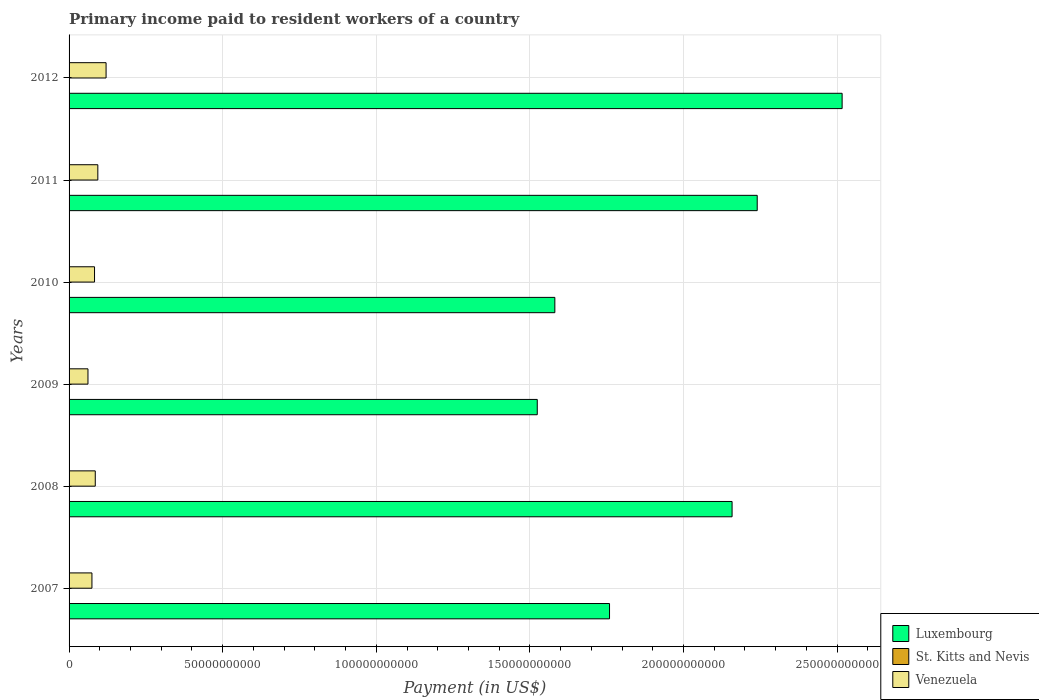Are the number of bars per tick equal to the number of legend labels?
Ensure brevity in your answer.  Yes. Are the number of bars on each tick of the Y-axis equal?
Provide a succinct answer. Yes. What is the label of the 3rd group of bars from the top?
Provide a succinct answer. 2010. In how many cases, is the number of bars for a given year not equal to the number of legend labels?
Ensure brevity in your answer.  0. What is the amount paid to workers in St. Kitts and Nevis in 2010?
Make the answer very short. 3.69e+07. Across all years, what is the maximum amount paid to workers in Luxembourg?
Provide a short and direct response. 2.52e+11. Across all years, what is the minimum amount paid to workers in Luxembourg?
Give a very brief answer. 1.52e+11. In which year was the amount paid to workers in Luxembourg minimum?
Your answer should be very brief. 2009. What is the total amount paid to workers in Venezuela in the graph?
Provide a short and direct response. 5.18e+1. What is the difference between the amount paid to workers in Venezuela in 2007 and that in 2011?
Your answer should be compact. -1.92e+09. What is the difference between the amount paid to workers in Luxembourg in 2010 and the amount paid to workers in St. Kitts and Nevis in 2009?
Ensure brevity in your answer.  1.58e+11. What is the average amount paid to workers in Venezuela per year?
Provide a succinct answer. 8.64e+09. In the year 2012, what is the difference between the amount paid to workers in Luxembourg and amount paid to workers in Venezuela?
Your response must be concise. 2.40e+11. In how many years, is the amount paid to workers in Venezuela greater than 70000000000 US$?
Your answer should be compact. 0. What is the ratio of the amount paid to workers in Venezuela in 2008 to that in 2009?
Give a very brief answer. 1.39. Is the difference between the amount paid to workers in Luxembourg in 2007 and 2010 greater than the difference between the amount paid to workers in Venezuela in 2007 and 2010?
Your response must be concise. Yes. What is the difference between the highest and the second highest amount paid to workers in Venezuela?
Keep it short and to the point. 2.68e+09. What is the difference between the highest and the lowest amount paid to workers in St. Kitts and Nevis?
Provide a succinct answer. 1.66e+07. In how many years, is the amount paid to workers in Luxembourg greater than the average amount paid to workers in Luxembourg taken over all years?
Make the answer very short. 3. What does the 3rd bar from the top in 2011 represents?
Keep it short and to the point. Luxembourg. What does the 2nd bar from the bottom in 2010 represents?
Make the answer very short. St. Kitts and Nevis. Is it the case that in every year, the sum of the amount paid to workers in St. Kitts and Nevis and amount paid to workers in Venezuela is greater than the amount paid to workers in Luxembourg?
Offer a terse response. No. Are the values on the major ticks of X-axis written in scientific E-notation?
Provide a succinct answer. No. Where does the legend appear in the graph?
Give a very brief answer. Bottom right. How are the legend labels stacked?
Offer a terse response. Vertical. What is the title of the graph?
Offer a terse response. Primary income paid to resident workers of a country. What is the label or title of the X-axis?
Ensure brevity in your answer.  Payment (in US$). What is the label or title of the Y-axis?
Your answer should be very brief. Years. What is the Payment (in US$) in Luxembourg in 2007?
Offer a terse response. 1.76e+11. What is the Payment (in US$) of St. Kitts and Nevis in 2007?
Offer a terse response. 4.57e+07. What is the Payment (in US$) of Venezuela in 2007?
Provide a short and direct response. 7.44e+09. What is the Payment (in US$) of Luxembourg in 2008?
Give a very brief answer. 2.16e+11. What is the Payment (in US$) of St. Kitts and Nevis in 2008?
Provide a short and direct response. 4.42e+07. What is the Payment (in US$) in Venezuela in 2008?
Provide a short and direct response. 8.53e+09. What is the Payment (in US$) in Luxembourg in 2009?
Make the answer very short. 1.52e+11. What is the Payment (in US$) of St. Kitts and Nevis in 2009?
Provide a short and direct response. 4.44e+07. What is the Payment (in US$) in Venezuela in 2009?
Keep it short and to the point. 6.15e+09. What is the Payment (in US$) of Luxembourg in 2010?
Your answer should be very brief. 1.58e+11. What is the Payment (in US$) in St. Kitts and Nevis in 2010?
Provide a short and direct response. 3.69e+07. What is the Payment (in US$) of Venezuela in 2010?
Your response must be concise. 8.28e+09. What is the Payment (in US$) in Luxembourg in 2011?
Keep it short and to the point. 2.24e+11. What is the Payment (in US$) in St. Kitts and Nevis in 2011?
Offer a terse response. 3.60e+07. What is the Payment (in US$) in Venezuela in 2011?
Offer a very short reply. 9.36e+09. What is the Payment (in US$) of Luxembourg in 2012?
Offer a terse response. 2.52e+11. What is the Payment (in US$) in St. Kitts and Nevis in 2012?
Make the answer very short. 2.91e+07. What is the Payment (in US$) in Venezuela in 2012?
Offer a very short reply. 1.20e+1. Across all years, what is the maximum Payment (in US$) in Luxembourg?
Your answer should be compact. 2.52e+11. Across all years, what is the maximum Payment (in US$) of St. Kitts and Nevis?
Ensure brevity in your answer.  4.57e+07. Across all years, what is the maximum Payment (in US$) in Venezuela?
Your response must be concise. 1.20e+1. Across all years, what is the minimum Payment (in US$) in Luxembourg?
Keep it short and to the point. 1.52e+11. Across all years, what is the minimum Payment (in US$) in St. Kitts and Nevis?
Make the answer very short. 2.91e+07. Across all years, what is the minimum Payment (in US$) in Venezuela?
Provide a short and direct response. 6.15e+09. What is the total Payment (in US$) of Luxembourg in the graph?
Offer a terse response. 1.18e+12. What is the total Payment (in US$) of St. Kitts and Nevis in the graph?
Offer a terse response. 2.36e+08. What is the total Payment (in US$) of Venezuela in the graph?
Give a very brief answer. 5.18e+1. What is the difference between the Payment (in US$) of Luxembourg in 2007 and that in 2008?
Offer a terse response. -3.99e+1. What is the difference between the Payment (in US$) in St. Kitts and Nevis in 2007 and that in 2008?
Give a very brief answer. 1.53e+06. What is the difference between the Payment (in US$) of Venezuela in 2007 and that in 2008?
Your response must be concise. -1.09e+09. What is the difference between the Payment (in US$) of Luxembourg in 2007 and that in 2009?
Make the answer very short. 2.35e+1. What is the difference between the Payment (in US$) of St. Kitts and Nevis in 2007 and that in 2009?
Your answer should be compact. 1.29e+06. What is the difference between the Payment (in US$) of Venezuela in 2007 and that in 2009?
Give a very brief answer. 1.29e+09. What is the difference between the Payment (in US$) of Luxembourg in 2007 and that in 2010?
Keep it short and to the point. 1.78e+1. What is the difference between the Payment (in US$) in St. Kitts and Nevis in 2007 and that in 2010?
Make the answer very short. 8.79e+06. What is the difference between the Payment (in US$) of Venezuela in 2007 and that in 2010?
Offer a terse response. -8.44e+08. What is the difference between the Payment (in US$) in Luxembourg in 2007 and that in 2011?
Provide a short and direct response. -4.81e+1. What is the difference between the Payment (in US$) of St. Kitts and Nevis in 2007 and that in 2011?
Make the answer very short. 9.65e+06. What is the difference between the Payment (in US$) in Venezuela in 2007 and that in 2011?
Offer a very short reply. -1.92e+09. What is the difference between the Payment (in US$) of Luxembourg in 2007 and that in 2012?
Provide a short and direct response. -7.57e+1. What is the difference between the Payment (in US$) of St. Kitts and Nevis in 2007 and that in 2012?
Ensure brevity in your answer.  1.66e+07. What is the difference between the Payment (in US$) in Venezuela in 2007 and that in 2012?
Your answer should be very brief. -4.60e+09. What is the difference between the Payment (in US$) in Luxembourg in 2008 and that in 2009?
Offer a terse response. 6.34e+1. What is the difference between the Payment (in US$) of St. Kitts and Nevis in 2008 and that in 2009?
Give a very brief answer. -2.35e+05. What is the difference between the Payment (in US$) in Venezuela in 2008 and that in 2009?
Ensure brevity in your answer.  2.38e+09. What is the difference between the Payment (in US$) in Luxembourg in 2008 and that in 2010?
Your response must be concise. 5.77e+1. What is the difference between the Payment (in US$) in St. Kitts and Nevis in 2008 and that in 2010?
Keep it short and to the point. 7.26e+06. What is the difference between the Payment (in US$) in Venezuela in 2008 and that in 2010?
Give a very brief answer. 2.42e+08. What is the difference between the Payment (in US$) in Luxembourg in 2008 and that in 2011?
Your answer should be very brief. -8.18e+09. What is the difference between the Payment (in US$) in St. Kitts and Nevis in 2008 and that in 2011?
Your answer should be compact. 8.13e+06. What is the difference between the Payment (in US$) of Venezuela in 2008 and that in 2011?
Your response must be concise. -8.35e+08. What is the difference between the Payment (in US$) of Luxembourg in 2008 and that in 2012?
Your response must be concise. -3.58e+1. What is the difference between the Payment (in US$) in St. Kitts and Nevis in 2008 and that in 2012?
Keep it short and to the point. 1.51e+07. What is the difference between the Payment (in US$) in Venezuela in 2008 and that in 2012?
Make the answer very short. -3.52e+09. What is the difference between the Payment (in US$) of Luxembourg in 2009 and that in 2010?
Your answer should be very brief. -5.72e+09. What is the difference between the Payment (in US$) of St. Kitts and Nevis in 2009 and that in 2010?
Ensure brevity in your answer.  7.50e+06. What is the difference between the Payment (in US$) of Venezuela in 2009 and that in 2010?
Provide a short and direct response. -2.14e+09. What is the difference between the Payment (in US$) of Luxembourg in 2009 and that in 2011?
Your answer should be compact. -7.16e+1. What is the difference between the Payment (in US$) of St. Kitts and Nevis in 2009 and that in 2011?
Provide a succinct answer. 8.36e+06. What is the difference between the Payment (in US$) in Venezuela in 2009 and that in 2011?
Ensure brevity in your answer.  -3.21e+09. What is the difference between the Payment (in US$) of Luxembourg in 2009 and that in 2012?
Provide a succinct answer. -9.92e+1. What is the difference between the Payment (in US$) in St. Kitts and Nevis in 2009 and that in 2012?
Ensure brevity in your answer.  1.53e+07. What is the difference between the Payment (in US$) in Venezuela in 2009 and that in 2012?
Your answer should be very brief. -5.90e+09. What is the difference between the Payment (in US$) of Luxembourg in 2010 and that in 2011?
Keep it short and to the point. -6.59e+1. What is the difference between the Payment (in US$) of St. Kitts and Nevis in 2010 and that in 2011?
Keep it short and to the point. 8.65e+05. What is the difference between the Payment (in US$) in Venezuela in 2010 and that in 2011?
Keep it short and to the point. -1.08e+09. What is the difference between the Payment (in US$) of Luxembourg in 2010 and that in 2012?
Your answer should be very brief. -9.35e+1. What is the difference between the Payment (in US$) of St. Kitts and Nevis in 2010 and that in 2012?
Your answer should be compact. 7.81e+06. What is the difference between the Payment (in US$) of Venezuela in 2010 and that in 2012?
Keep it short and to the point. -3.76e+09. What is the difference between the Payment (in US$) of Luxembourg in 2011 and that in 2012?
Provide a succinct answer. -2.76e+1. What is the difference between the Payment (in US$) of St. Kitts and Nevis in 2011 and that in 2012?
Provide a short and direct response. 6.94e+06. What is the difference between the Payment (in US$) of Venezuela in 2011 and that in 2012?
Keep it short and to the point. -2.68e+09. What is the difference between the Payment (in US$) of Luxembourg in 2007 and the Payment (in US$) of St. Kitts and Nevis in 2008?
Provide a short and direct response. 1.76e+11. What is the difference between the Payment (in US$) in Luxembourg in 2007 and the Payment (in US$) in Venezuela in 2008?
Your response must be concise. 1.67e+11. What is the difference between the Payment (in US$) of St. Kitts and Nevis in 2007 and the Payment (in US$) of Venezuela in 2008?
Provide a short and direct response. -8.48e+09. What is the difference between the Payment (in US$) of Luxembourg in 2007 and the Payment (in US$) of St. Kitts and Nevis in 2009?
Make the answer very short. 1.76e+11. What is the difference between the Payment (in US$) in Luxembourg in 2007 and the Payment (in US$) in Venezuela in 2009?
Provide a succinct answer. 1.70e+11. What is the difference between the Payment (in US$) in St. Kitts and Nevis in 2007 and the Payment (in US$) in Venezuela in 2009?
Your response must be concise. -6.10e+09. What is the difference between the Payment (in US$) in Luxembourg in 2007 and the Payment (in US$) in St. Kitts and Nevis in 2010?
Offer a very short reply. 1.76e+11. What is the difference between the Payment (in US$) of Luxembourg in 2007 and the Payment (in US$) of Venezuela in 2010?
Keep it short and to the point. 1.68e+11. What is the difference between the Payment (in US$) of St. Kitts and Nevis in 2007 and the Payment (in US$) of Venezuela in 2010?
Provide a succinct answer. -8.24e+09. What is the difference between the Payment (in US$) of Luxembourg in 2007 and the Payment (in US$) of St. Kitts and Nevis in 2011?
Provide a short and direct response. 1.76e+11. What is the difference between the Payment (in US$) in Luxembourg in 2007 and the Payment (in US$) in Venezuela in 2011?
Provide a succinct answer. 1.67e+11. What is the difference between the Payment (in US$) in St. Kitts and Nevis in 2007 and the Payment (in US$) in Venezuela in 2011?
Give a very brief answer. -9.32e+09. What is the difference between the Payment (in US$) of Luxembourg in 2007 and the Payment (in US$) of St. Kitts and Nevis in 2012?
Make the answer very short. 1.76e+11. What is the difference between the Payment (in US$) in Luxembourg in 2007 and the Payment (in US$) in Venezuela in 2012?
Provide a short and direct response. 1.64e+11. What is the difference between the Payment (in US$) in St. Kitts and Nevis in 2007 and the Payment (in US$) in Venezuela in 2012?
Your answer should be very brief. -1.20e+1. What is the difference between the Payment (in US$) of Luxembourg in 2008 and the Payment (in US$) of St. Kitts and Nevis in 2009?
Ensure brevity in your answer.  2.16e+11. What is the difference between the Payment (in US$) of Luxembourg in 2008 and the Payment (in US$) of Venezuela in 2009?
Offer a very short reply. 2.10e+11. What is the difference between the Payment (in US$) of St. Kitts and Nevis in 2008 and the Payment (in US$) of Venezuela in 2009?
Make the answer very short. -6.10e+09. What is the difference between the Payment (in US$) of Luxembourg in 2008 and the Payment (in US$) of St. Kitts and Nevis in 2010?
Your answer should be compact. 2.16e+11. What is the difference between the Payment (in US$) of Luxembourg in 2008 and the Payment (in US$) of Venezuela in 2010?
Make the answer very short. 2.08e+11. What is the difference between the Payment (in US$) of St. Kitts and Nevis in 2008 and the Payment (in US$) of Venezuela in 2010?
Your answer should be compact. -8.24e+09. What is the difference between the Payment (in US$) in Luxembourg in 2008 and the Payment (in US$) in St. Kitts and Nevis in 2011?
Your answer should be compact. 2.16e+11. What is the difference between the Payment (in US$) of Luxembourg in 2008 and the Payment (in US$) of Venezuela in 2011?
Your response must be concise. 2.06e+11. What is the difference between the Payment (in US$) in St. Kitts and Nevis in 2008 and the Payment (in US$) in Venezuela in 2011?
Keep it short and to the point. -9.32e+09. What is the difference between the Payment (in US$) of Luxembourg in 2008 and the Payment (in US$) of St. Kitts and Nevis in 2012?
Provide a short and direct response. 2.16e+11. What is the difference between the Payment (in US$) of Luxembourg in 2008 and the Payment (in US$) of Venezuela in 2012?
Give a very brief answer. 2.04e+11. What is the difference between the Payment (in US$) in St. Kitts and Nevis in 2008 and the Payment (in US$) in Venezuela in 2012?
Make the answer very short. -1.20e+1. What is the difference between the Payment (in US$) in Luxembourg in 2009 and the Payment (in US$) in St. Kitts and Nevis in 2010?
Your answer should be very brief. 1.52e+11. What is the difference between the Payment (in US$) in Luxembourg in 2009 and the Payment (in US$) in Venezuela in 2010?
Provide a succinct answer. 1.44e+11. What is the difference between the Payment (in US$) of St. Kitts and Nevis in 2009 and the Payment (in US$) of Venezuela in 2010?
Offer a terse response. -8.24e+09. What is the difference between the Payment (in US$) in Luxembourg in 2009 and the Payment (in US$) in St. Kitts and Nevis in 2011?
Provide a succinct answer. 1.52e+11. What is the difference between the Payment (in US$) in Luxembourg in 2009 and the Payment (in US$) in Venezuela in 2011?
Your answer should be compact. 1.43e+11. What is the difference between the Payment (in US$) in St. Kitts and Nevis in 2009 and the Payment (in US$) in Venezuela in 2011?
Provide a short and direct response. -9.32e+09. What is the difference between the Payment (in US$) in Luxembourg in 2009 and the Payment (in US$) in St. Kitts and Nevis in 2012?
Provide a short and direct response. 1.52e+11. What is the difference between the Payment (in US$) in Luxembourg in 2009 and the Payment (in US$) in Venezuela in 2012?
Provide a succinct answer. 1.40e+11. What is the difference between the Payment (in US$) of St. Kitts and Nevis in 2009 and the Payment (in US$) of Venezuela in 2012?
Keep it short and to the point. -1.20e+1. What is the difference between the Payment (in US$) of Luxembourg in 2010 and the Payment (in US$) of St. Kitts and Nevis in 2011?
Your response must be concise. 1.58e+11. What is the difference between the Payment (in US$) of Luxembourg in 2010 and the Payment (in US$) of Venezuela in 2011?
Offer a very short reply. 1.49e+11. What is the difference between the Payment (in US$) in St. Kitts and Nevis in 2010 and the Payment (in US$) in Venezuela in 2011?
Offer a terse response. -9.33e+09. What is the difference between the Payment (in US$) in Luxembourg in 2010 and the Payment (in US$) in St. Kitts and Nevis in 2012?
Keep it short and to the point. 1.58e+11. What is the difference between the Payment (in US$) of Luxembourg in 2010 and the Payment (in US$) of Venezuela in 2012?
Your response must be concise. 1.46e+11. What is the difference between the Payment (in US$) of St. Kitts and Nevis in 2010 and the Payment (in US$) of Venezuela in 2012?
Offer a terse response. -1.20e+1. What is the difference between the Payment (in US$) of Luxembourg in 2011 and the Payment (in US$) of St. Kitts and Nevis in 2012?
Your answer should be very brief. 2.24e+11. What is the difference between the Payment (in US$) in Luxembourg in 2011 and the Payment (in US$) in Venezuela in 2012?
Give a very brief answer. 2.12e+11. What is the difference between the Payment (in US$) in St. Kitts and Nevis in 2011 and the Payment (in US$) in Venezuela in 2012?
Offer a terse response. -1.20e+1. What is the average Payment (in US$) in Luxembourg per year?
Give a very brief answer. 1.96e+11. What is the average Payment (in US$) of St. Kitts and Nevis per year?
Make the answer very short. 3.94e+07. What is the average Payment (in US$) in Venezuela per year?
Offer a very short reply. 8.64e+09. In the year 2007, what is the difference between the Payment (in US$) in Luxembourg and Payment (in US$) in St. Kitts and Nevis?
Give a very brief answer. 1.76e+11. In the year 2007, what is the difference between the Payment (in US$) of Luxembourg and Payment (in US$) of Venezuela?
Make the answer very short. 1.68e+11. In the year 2007, what is the difference between the Payment (in US$) of St. Kitts and Nevis and Payment (in US$) of Venezuela?
Make the answer very short. -7.40e+09. In the year 2008, what is the difference between the Payment (in US$) in Luxembourg and Payment (in US$) in St. Kitts and Nevis?
Keep it short and to the point. 2.16e+11. In the year 2008, what is the difference between the Payment (in US$) in Luxembourg and Payment (in US$) in Venezuela?
Ensure brevity in your answer.  2.07e+11. In the year 2008, what is the difference between the Payment (in US$) in St. Kitts and Nevis and Payment (in US$) in Venezuela?
Your answer should be very brief. -8.48e+09. In the year 2009, what is the difference between the Payment (in US$) of Luxembourg and Payment (in US$) of St. Kitts and Nevis?
Keep it short and to the point. 1.52e+11. In the year 2009, what is the difference between the Payment (in US$) of Luxembourg and Payment (in US$) of Venezuela?
Offer a terse response. 1.46e+11. In the year 2009, what is the difference between the Payment (in US$) in St. Kitts and Nevis and Payment (in US$) in Venezuela?
Provide a short and direct response. -6.10e+09. In the year 2010, what is the difference between the Payment (in US$) in Luxembourg and Payment (in US$) in St. Kitts and Nevis?
Your answer should be compact. 1.58e+11. In the year 2010, what is the difference between the Payment (in US$) in Luxembourg and Payment (in US$) in Venezuela?
Your answer should be very brief. 1.50e+11. In the year 2010, what is the difference between the Payment (in US$) of St. Kitts and Nevis and Payment (in US$) of Venezuela?
Make the answer very short. -8.25e+09. In the year 2011, what is the difference between the Payment (in US$) in Luxembourg and Payment (in US$) in St. Kitts and Nevis?
Ensure brevity in your answer.  2.24e+11. In the year 2011, what is the difference between the Payment (in US$) of Luxembourg and Payment (in US$) of Venezuela?
Your answer should be very brief. 2.15e+11. In the year 2011, what is the difference between the Payment (in US$) in St. Kitts and Nevis and Payment (in US$) in Venezuela?
Keep it short and to the point. -9.33e+09. In the year 2012, what is the difference between the Payment (in US$) in Luxembourg and Payment (in US$) in St. Kitts and Nevis?
Provide a succinct answer. 2.52e+11. In the year 2012, what is the difference between the Payment (in US$) in Luxembourg and Payment (in US$) in Venezuela?
Provide a short and direct response. 2.40e+11. In the year 2012, what is the difference between the Payment (in US$) of St. Kitts and Nevis and Payment (in US$) of Venezuela?
Provide a short and direct response. -1.20e+1. What is the ratio of the Payment (in US$) of Luxembourg in 2007 to that in 2008?
Provide a short and direct response. 0.82. What is the ratio of the Payment (in US$) in St. Kitts and Nevis in 2007 to that in 2008?
Offer a very short reply. 1.03. What is the ratio of the Payment (in US$) of Venezuela in 2007 to that in 2008?
Ensure brevity in your answer.  0.87. What is the ratio of the Payment (in US$) of Luxembourg in 2007 to that in 2009?
Your answer should be compact. 1.15. What is the ratio of the Payment (in US$) in St. Kitts and Nevis in 2007 to that in 2009?
Provide a short and direct response. 1.03. What is the ratio of the Payment (in US$) of Venezuela in 2007 to that in 2009?
Provide a short and direct response. 1.21. What is the ratio of the Payment (in US$) of Luxembourg in 2007 to that in 2010?
Provide a succinct answer. 1.11. What is the ratio of the Payment (in US$) in St. Kitts and Nevis in 2007 to that in 2010?
Offer a terse response. 1.24. What is the ratio of the Payment (in US$) in Venezuela in 2007 to that in 2010?
Your response must be concise. 0.9. What is the ratio of the Payment (in US$) of Luxembourg in 2007 to that in 2011?
Offer a very short reply. 0.79. What is the ratio of the Payment (in US$) of St. Kitts and Nevis in 2007 to that in 2011?
Offer a very short reply. 1.27. What is the ratio of the Payment (in US$) of Venezuela in 2007 to that in 2011?
Ensure brevity in your answer.  0.79. What is the ratio of the Payment (in US$) in Luxembourg in 2007 to that in 2012?
Your answer should be compact. 0.7. What is the ratio of the Payment (in US$) of St. Kitts and Nevis in 2007 to that in 2012?
Your answer should be very brief. 1.57. What is the ratio of the Payment (in US$) in Venezuela in 2007 to that in 2012?
Make the answer very short. 0.62. What is the ratio of the Payment (in US$) of Luxembourg in 2008 to that in 2009?
Ensure brevity in your answer.  1.42. What is the ratio of the Payment (in US$) in St. Kitts and Nevis in 2008 to that in 2009?
Ensure brevity in your answer.  0.99. What is the ratio of the Payment (in US$) of Venezuela in 2008 to that in 2009?
Offer a very short reply. 1.39. What is the ratio of the Payment (in US$) of Luxembourg in 2008 to that in 2010?
Make the answer very short. 1.36. What is the ratio of the Payment (in US$) in St. Kitts and Nevis in 2008 to that in 2010?
Your response must be concise. 1.2. What is the ratio of the Payment (in US$) of Venezuela in 2008 to that in 2010?
Ensure brevity in your answer.  1.03. What is the ratio of the Payment (in US$) in Luxembourg in 2008 to that in 2011?
Provide a short and direct response. 0.96. What is the ratio of the Payment (in US$) of St. Kitts and Nevis in 2008 to that in 2011?
Ensure brevity in your answer.  1.23. What is the ratio of the Payment (in US$) of Venezuela in 2008 to that in 2011?
Keep it short and to the point. 0.91. What is the ratio of the Payment (in US$) in Luxembourg in 2008 to that in 2012?
Keep it short and to the point. 0.86. What is the ratio of the Payment (in US$) in St. Kitts and Nevis in 2008 to that in 2012?
Keep it short and to the point. 1.52. What is the ratio of the Payment (in US$) of Venezuela in 2008 to that in 2012?
Your response must be concise. 0.71. What is the ratio of the Payment (in US$) in Luxembourg in 2009 to that in 2010?
Your response must be concise. 0.96. What is the ratio of the Payment (in US$) in St. Kitts and Nevis in 2009 to that in 2010?
Give a very brief answer. 1.2. What is the ratio of the Payment (in US$) in Venezuela in 2009 to that in 2010?
Provide a short and direct response. 0.74. What is the ratio of the Payment (in US$) of Luxembourg in 2009 to that in 2011?
Ensure brevity in your answer.  0.68. What is the ratio of the Payment (in US$) in St. Kitts and Nevis in 2009 to that in 2011?
Ensure brevity in your answer.  1.23. What is the ratio of the Payment (in US$) of Venezuela in 2009 to that in 2011?
Your response must be concise. 0.66. What is the ratio of the Payment (in US$) of Luxembourg in 2009 to that in 2012?
Ensure brevity in your answer.  0.61. What is the ratio of the Payment (in US$) in St. Kitts and Nevis in 2009 to that in 2012?
Offer a terse response. 1.53. What is the ratio of the Payment (in US$) of Venezuela in 2009 to that in 2012?
Offer a terse response. 0.51. What is the ratio of the Payment (in US$) of Luxembourg in 2010 to that in 2011?
Ensure brevity in your answer.  0.71. What is the ratio of the Payment (in US$) of Venezuela in 2010 to that in 2011?
Keep it short and to the point. 0.89. What is the ratio of the Payment (in US$) in Luxembourg in 2010 to that in 2012?
Offer a very short reply. 0.63. What is the ratio of the Payment (in US$) of St. Kitts and Nevis in 2010 to that in 2012?
Give a very brief answer. 1.27. What is the ratio of the Payment (in US$) in Venezuela in 2010 to that in 2012?
Keep it short and to the point. 0.69. What is the ratio of the Payment (in US$) in Luxembourg in 2011 to that in 2012?
Offer a terse response. 0.89. What is the ratio of the Payment (in US$) in St. Kitts and Nevis in 2011 to that in 2012?
Offer a terse response. 1.24. What is the ratio of the Payment (in US$) in Venezuela in 2011 to that in 2012?
Keep it short and to the point. 0.78. What is the difference between the highest and the second highest Payment (in US$) in Luxembourg?
Offer a very short reply. 2.76e+1. What is the difference between the highest and the second highest Payment (in US$) in St. Kitts and Nevis?
Keep it short and to the point. 1.29e+06. What is the difference between the highest and the second highest Payment (in US$) in Venezuela?
Make the answer very short. 2.68e+09. What is the difference between the highest and the lowest Payment (in US$) of Luxembourg?
Your answer should be compact. 9.92e+1. What is the difference between the highest and the lowest Payment (in US$) of St. Kitts and Nevis?
Make the answer very short. 1.66e+07. What is the difference between the highest and the lowest Payment (in US$) of Venezuela?
Offer a terse response. 5.90e+09. 